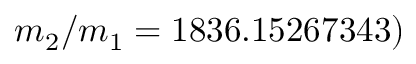Convert formula to latex. <formula><loc_0><loc_0><loc_500><loc_500>m _ { 2 } / m _ { 1 } = 1 8 3 6 . 1 5 2 6 7 3 4 3 )</formula> 